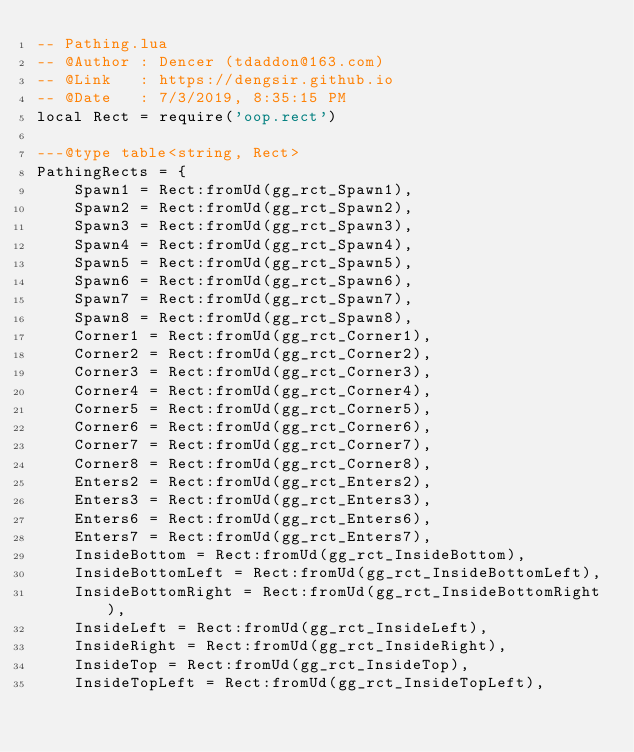Convert code to text. <code><loc_0><loc_0><loc_500><loc_500><_Lua_>-- Pathing.lua
-- @Author : Dencer (tdaddon@163.com)
-- @Link   : https://dengsir.github.io
-- @Date   : 7/3/2019, 8:35:15 PM
local Rect = require('oop.rect')

---@type table<string, Rect>
PathingRects = {
    Spawn1 = Rect:fromUd(gg_rct_Spawn1),
    Spawn2 = Rect:fromUd(gg_rct_Spawn2),
    Spawn3 = Rect:fromUd(gg_rct_Spawn3),
    Spawn4 = Rect:fromUd(gg_rct_Spawn4),
    Spawn5 = Rect:fromUd(gg_rct_Spawn5),
    Spawn6 = Rect:fromUd(gg_rct_Spawn6),
    Spawn7 = Rect:fromUd(gg_rct_Spawn7),
    Spawn8 = Rect:fromUd(gg_rct_Spawn8),
    Corner1 = Rect:fromUd(gg_rct_Corner1),
    Corner2 = Rect:fromUd(gg_rct_Corner2),
    Corner3 = Rect:fromUd(gg_rct_Corner3),
    Corner4 = Rect:fromUd(gg_rct_Corner4),
    Corner5 = Rect:fromUd(gg_rct_Corner5),
    Corner6 = Rect:fromUd(gg_rct_Corner6),
    Corner7 = Rect:fromUd(gg_rct_Corner7),
    Corner8 = Rect:fromUd(gg_rct_Corner8),
    Enters2 = Rect:fromUd(gg_rct_Enters2),
    Enters3 = Rect:fromUd(gg_rct_Enters3),
    Enters6 = Rect:fromUd(gg_rct_Enters6),
    Enters7 = Rect:fromUd(gg_rct_Enters7),
    InsideBottom = Rect:fromUd(gg_rct_InsideBottom),
    InsideBottomLeft = Rect:fromUd(gg_rct_InsideBottomLeft),
    InsideBottomRight = Rect:fromUd(gg_rct_InsideBottomRight),
    InsideLeft = Rect:fromUd(gg_rct_InsideLeft),
    InsideRight = Rect:fromUd(gg_rct_InsideRight),
    InsideTop = Rect:fromUd(gg_rct_InsideTop),
    InsideTopLeft = Rect:fromUd(gg_rct_InsideTopLeft),</code> 